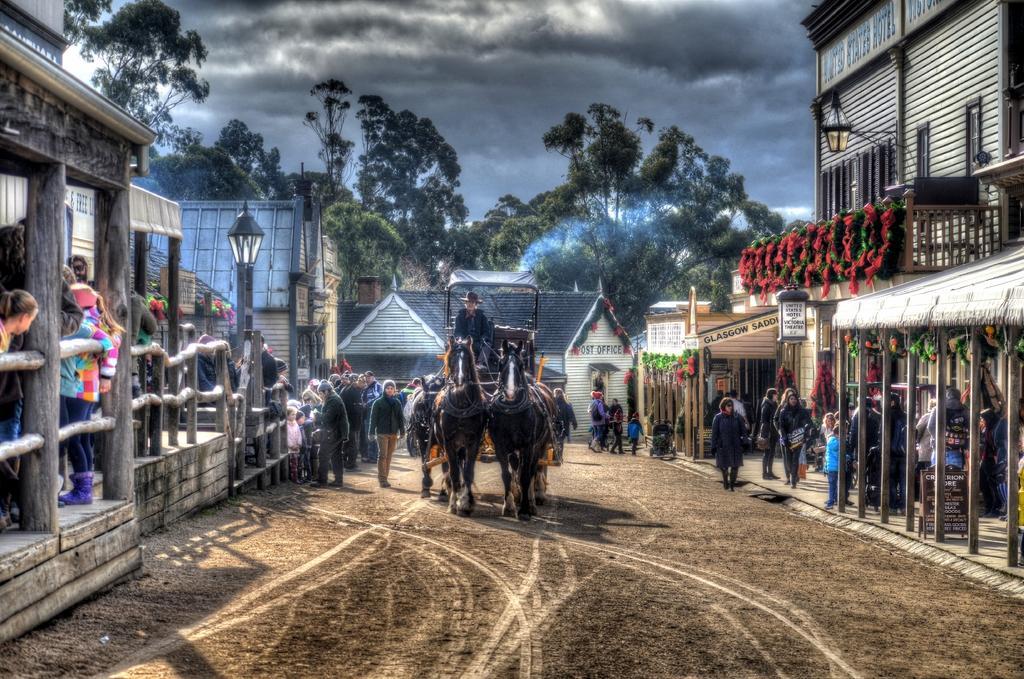Can you describe this image briefly? In this image in the middle, there are horses and cart, on that court there is a person. On the right there are buildings, some people, plants, trees, sky and clouds. On the left there are buildings, street lights, people, trees. 